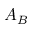Convert formula to latex. <formula><loc_0><loc_0><loc_500><loc_500>A _ { B }</formula> 